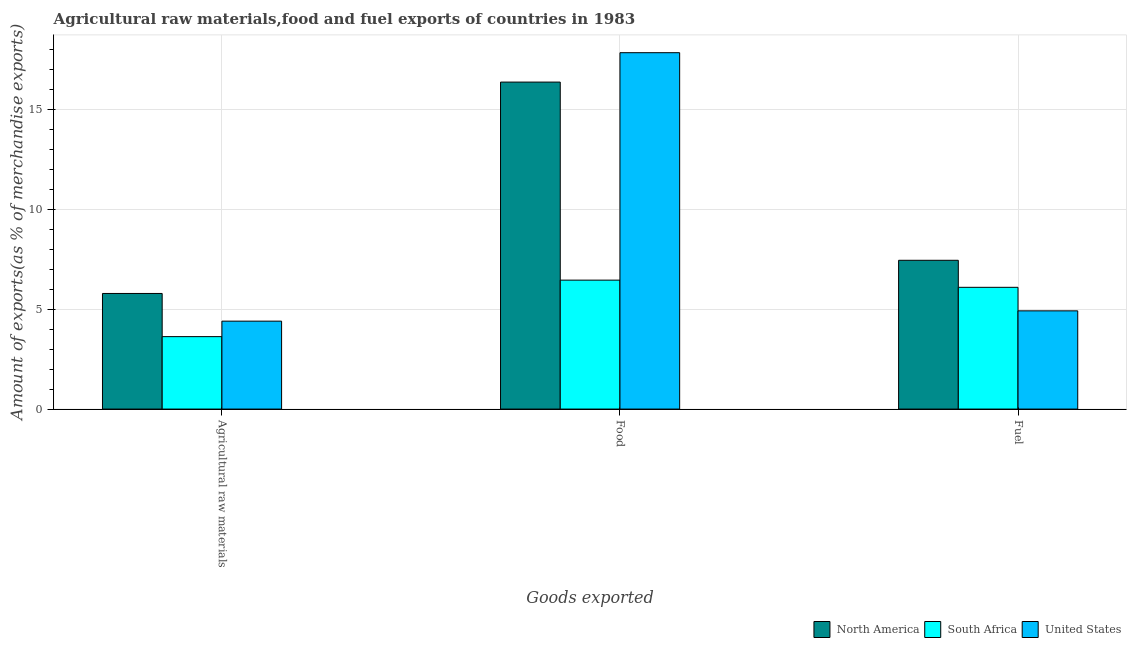How many groups of bars are there?
Provide a short and direct response. 3. How many bars are there on the 1st tick from the right?
Offer a terse response. 3. What is the label of the 3rd group of bars from the left?
Provide a short and direct response. Fuel. What is the percentage of fuel exports in North America?
Your answer should be very brief. 7.44. Across all countries, what is the maximum percentage of food exports?
Make the answer very short. 17.82. Across all countries, what is the minimum percentage of raw materials exports?
Make the answer very short. 3.62. In which country was the percentage of raw materials exports maximum?
Offer a terse response. North America. In which country was the percentage of fuel exports minimum?
Provide a short and direct response. United States. What is the total percentage of fuel exports in the graph?
Provide a succinct answer. 18.44. What is the difference between the percentage of food exports in United States and that in North America?
Provide a short and direct response. 1.47. What is the difference between the percentage of fuel exports in South Africa and the percentage of raw materials exports in United States?
Ensure brevity in your answer.  1.69. What is the average percentage of food exports per country?
Ensure brevity in your answer.  13.54. What is the difference between the percentage of raw materials exports and percentage of food exports in South Africa?
Your answer should be very brief. -2.82. What is the ratio of the percentage of food exports in United States to that in South Africa?
Provide a succinct answer. 2.76. Is the difference between the percentage of fuel exports in United States and North America greater than the difference between the percentage of raw materials exports in United States and North America?
Offer a very short reply. No. What is the difference between the highest and the second highest percentage of raw materials exports?
Keep it short and to the point. 1.38. What is the difference between the highest and the lowest percentage of raw materials exports?
Provide a succinct answer. 2.16. Is the sum of the percentage of fuel exports in United States and South Africa greater than the maximum percentage of raw materials exports across all countries?
Offer a terse response. Yes. What does the 2nd bar from the left in Fuel represents?
Ensure brevity in your answer.  South Africa. How many bars are there?
Give a very brief answer. 9. How many countries are there in the graph?
Your answer should be very brief. 3. What is the difference between two consecutive major ticks on the Y-axis?
Keep it short and to the point. 5. Are the values on the major ticks of Y-axis written in scientific E-notation?
Your answer should be compact. No. How are the legend labels stacked?
Provide a short and direct response. Horizontal. What is the title of the graph?
Give a very brief answer. Agricultural raw materials,food and fuel exports of countries in 1983. What is the label or title of the X-axis?
Provide a short and direct response. Goods exported. What is the label or title of the Y-axis?
Offer a terse response. Amount of exports(as % of merchandise exports). What is the Amount of exports(as % of merchandise exports) in North America in Agricultural raw materials?
Keep it short and to the point. 5.78. What is the Amount of exports(as % of merchandise exports) of South Africa in Agricultural raw materials?
Your answer should be compact. 3.62. What is the Amount of exports(as % of merchandise exports) of United States in Agricultural raw materials?
Provide a short and direct response. 4.4. What is the Amount of exports(as % of merchandise exports) in North America in Food?
Offer a terse response. 16.35. What is the Amount of exports(as % of merchandise exports) in South Africa in Food?
Keep it short and to the point. 6.45. What is the Amount of exports(as % of merchandise exports) of United States in Food?
Offer a terse response. 17.82. What is the Amount of exports(as % of merchandise exports) in North America in Fuel?
Ensure brevity in your answer.  7.44. What is the Amount of exports(as % of merchandise exports) in South Africa in Fuel?
Make the answer very short. 6.09. What is the Amount of exports(as % of merchandise exports) in United States in Fuel?
Your answer should be very brief. 4.91. Across all Goods exported, what is the maximum Amount of exports(as % of merchandise exports) in North America?
Offer a very short reply. 16.35. Across all Goods exported, what is the maximum Amount of exports(as % of merchandise exports) of South Africa?
Ensure brevity in your answer.  6.45. Across all Goods exported, what is the maximum Amount of exports(as % of merchandise exports) of United States?
Offer a terse response. 17.82. Across all Goods exported, what is the minimum Amount of exports(as % of merchandise exports) in North America?
Ensure brevity in your answer.  5.78. Across all Goods exported, what is the minimum Amount of exports(as % of merchandise exports) of South Africa?
Your answer should be very brief. 3.62. Across all Goods exported, what is the minimum Amount of exports(as % of merchandise exports) in United States?
Ensure brevity in your answer.  4.4. What is the total Amount of exports(as % of merchandise exports) in North America in the graph?
Provide a short and direct response. 29.57. What is the total Amount of exports(as % of merchandise exports) of South Africa in the graph?
Make the answer very short. 16.16. What is the total Amount of exports(as % of merchandise exports) in United States in the graph?
Ensure brevity in your answer.  27.12. What is the difference between the Amount of exports(as % of merchandise exports) of North America in Agricultural raw materials and that in Food?
Give a very brief answer. -10.57. What is the difference between the Amount of exports(as % of merchandise exports) in South Africa in Agricultural raw materials and that in Food?
Your response must be concise. -2.82. What is the difference between the Amount of exports(as % of merchandise exports) of United States in Agricultural raw materials and that in Food?
Give a very brief answer. -13.42. What is the difference between the Amount of exports(as % of merchandise exports) of North America in Agricultural raw materials and that in Fuel?
Give a very brief answer. -1.66. What is the difference between the Amount of exports(as % of merchandise exports) of South Africa in Agricultural raw materials and that in Fuel?
Provide a short and direct response. -2.47. What is the difference between the Amount of exports(as % of merchandise exports) in United States in Agricultural raw materials and that in Fuel?
Provide a short and direct response. -0.51. What is the difference between the Amount of exports(as % of merchandise exports) in North America in Food and that in Fuel?
Your answer should be very brief. 8.91. What is the difference between the Amount of exports(as % of merchandise exports) in South Africa in Food and that in Fuel?
Offer a very short reply. 0.36. What is the difference between the Amount of exports(as % of merchandise exports) in United States in Food and that in Fuel?
Keep it short and to the point. 12.91. What is the difference between the Amount of exports(as % of merchandise exports) in North America in Agricultural raw materials and the Amount of exports(as % of merchandise exports) in South Africa in Food?
Your response must be concise. -0.67. What is the difference between the Amount of exports(as % of merchandise exports) of North America in Agricultural raw materials and the Amount of exports(as % of merchandise exports) of United States in Food?
Your response must be concise. -12.04. What is the difference between the Amount of exports(as % of merchandise exports) in South Africa in Agricultural raw materials and the Amount of exports(as % of merchandise exports) in United States in Food?
Offer a very short reply. -14.2. What is the difference between the Amount of exports(as % of merchandise exports) in North America in Agricultural raw materials and the Amount of exports(as % of merchandise exports) in South Africa in Fuel?
Your response must be concise. -0.31. What is the difference between the Amount of exports(as % of merchandise exports) in North America in Agricultural raw materials and the Amount of exports(as % of merchandise exports) in United States in Fuel?
Your answer should be compact. 0.87. What is the difference between the Amount of exports(as % of merchandise exports) of South Africa in Agricultural raw materials and the Amount of exports(as % of merchandise exports) of United States in Fuel?
Offer a very short reply. -1.29. What is the difference between the Amount of exports(as % of merchandise exports) in North America in Food and the Amount of exports(as % of merchandise exports) in South Africa in Fuel?
Ensure brevity in your answer.  10.26. What is the difference between the Amount of exports(as % of merchandise exports) in North America in Food and the Amount of exports(as % of merchandise exports) in United States in Fuel?
Ensure brevity in your answer.  11.44. What is the difference between the Amount of exports(as % of merchandise exports) in South Africa in Food and the Amount of exports(as % of merchandise exports) in United States in Fuel?
Ensure brevity in your answer.  1.54. What is the average Amount of exports(as % of merchandise exports) in North America per Goods exported?
Make the answer very short. 9.86. What is the average Amount of exports(as % of merchandise exports) of South Africa per Goods exported?
Your answer should be very brief. 5.39. What is the average Amount of exports(as % of merchandise exports) in United States per Goods exported?
Your answer should be very brief. 9.04. What is the difference between the Amount of exports(as % of merchandise exports) of North America and Amount of exports(as % of merchandise exports) of South Africa in Agricultural raw materials?
Keep it short and to the point. 2.16. What is the difference between the Amount of exports(as % of merchandise exports) in North America and Amount of exports(as % of merchandise exports) in United States in Agricultural raw materials?
Provide a succinct answer. 1.38. What is the difference between the Amount of exports(as % of merchandise exports) in South Africa and Amount of exports(as % of merchandise exports) in United States in Agricultural raw materials?
Offer a very short reply. -0.77. What is the difference between the Amount of exports(as % of merchandise exports) in North America and Amount of exports(as % of merchandise exports) in South Africa in Food?
Ensure brevity in your answer.  9.9. What is the difference between the Amount of exports(as % of merchandise exports) of North America and Amount of exports(as % of merchandise exports) of United States in Food?
Keep it short and to the point. -1.47. What is the difference between the Amount of exports(as % of merchandise exports) in South Africa and Amount of exports(as % of merchandise exports) in United States in Food?
Give a very brief answer. -11.37. What is the difference between the Amount of exports(as % of merchandise exports) in North America and Amount of exports(as % of merchandise exports) in South Africa in Fuel?
Provide a succinct answer. 1.35. What is the difference between the Amount of exports(as % of merchandise exports) in North America and Amount of exports(as % of merchandise exports) in United States in Fuel?
Make the answer very short. 2.53. What is the difference between the Amount of exports(as % of merchandise exports) in South Africa and Amount of exports(as % of merchandise exports) in United States in Fuel?
Ensure brevity in your answer.  1.18. What is the ratio of the Amount of exports(as % of merchandise exports) in North America in Agricultural raw materials to that in Food?
Offer a very short reply. 0.35. What is the ratio of the Amount of exports(as % of merchandise exports) in South Africa in Agricultural raw materials to that in Food?
Offer a terse response. 0.56. What is the ratio of the Amount of exports(as % of merchandise exports) of United States in Agricultural raw materials to that in Food?
Your answer should be very brief. 0.25. What is the ratio of the Amount of exports(as % of merchandise exports) of North America in Agricultural raw materials to that in Fuel?
Ensure brevity in your answer.  0.78. What is the ratio of the Amount of exports(as % of merchandise exports) in South Africa in Agricultural raw materials to that in Fuel?
Offer a very short reply. 0.59. What is the ratio of the Amount of exports(as % of merchandise exports) of United States in Agricultural raw materials to that in Fuel?
Offer a very short reply. 0.9. What is the ratio of the Amount of exports(as % of merchandise exports) in North America in Food to that in Fuel?
Keep it short and to the point. 2.2. What is the ratio of the Amount of exports(as % of merchandise exports) in South Africa in Food to that in Fuel?
Offer a very short reply. 1.06. What is the ratio of the Amount of exports(as % of merchandise exports) in United States in Food to that in Fuel?
Provide a succinct answer. 3.63. What is the difference between the highest and the second highest Amount of exports(as % of merchandise exports) of North America?
Your answer should be compact. 8.91. What is the difference between the highest and the second highest Amount of exports(as % of merchandise exports) in South Africa?
Give a very brief answer. 0.36. What is the difference between the highest and the second highest Amount of exports(as % of merchandise exports) in United States?
Offer a very short reply. 12.91. What is the difference between the highest and the lowest Amount of exports(as % of merchandise exports) of North America?
Your answer should be compact. 10.57. What is the difference between the highest and the lowest Amount of exports(as % of merchandise exports) in South Africa?
Provide a succinct answer. 2.82. What is the difference between the highest and the lowest Amount of exports(as % of merchandise exports) of United States?
Offer a very short reply. 13.42. 